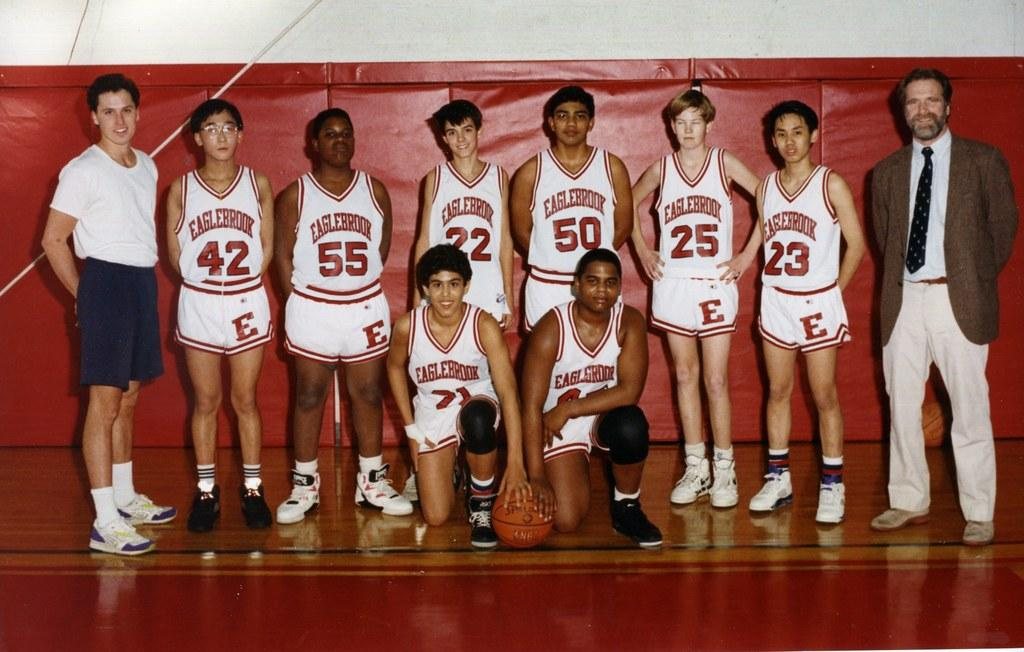<image>
Give a short and clear explanation of the subsequent image. Basketball players from Eaglebrook are posing for a picture with their coaches. 